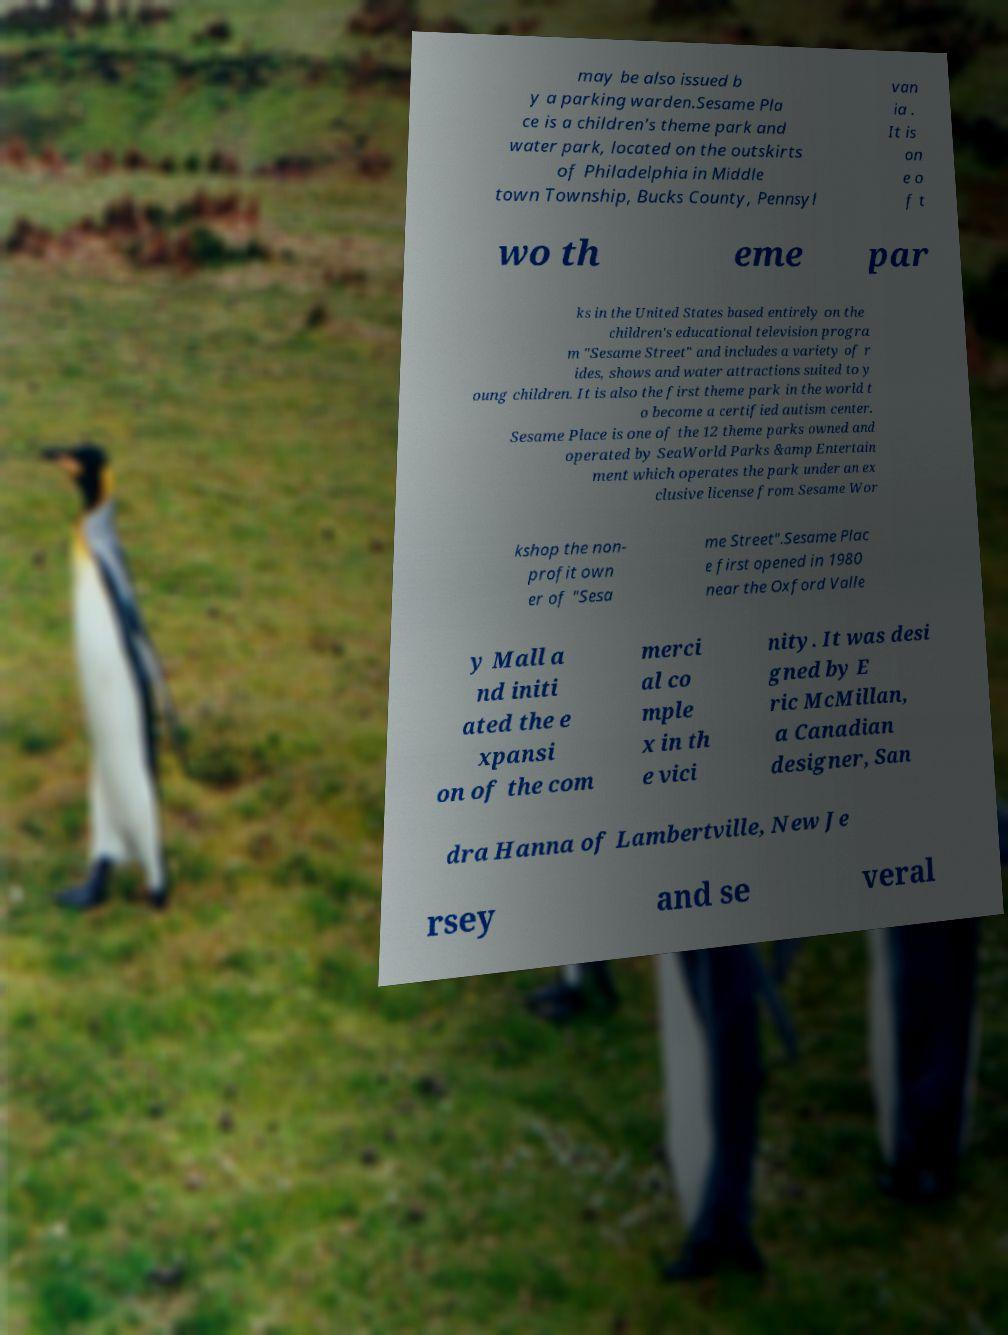Could you extract and type out the text from this image? may be also issued b y a parking warden.Sesame Pla ce is a children's theme park and water park, located on the outskirts of Philadelphia in Middle town Township, Bucks County, Pennsyl van ia . It is on e o f t wo th eme par ks in the United States based entirely on the children's educational television progra m "Sesame Street" and includes a variety of r ides, shows and water attractions suited to y oung children. It is also the first theme park in the world t o become a certified autism center. Sesame Place is one of the 12 theme parks owned and operated by SeaWorld Parks &amp Entertain ment which operates the park under an ex clusive license from Sesame Wor kshop the non- profit own er of "Sesa me Street".Sesame Plac e first opened in 1980 near the Oxford Valle y Mall a nd initi ated the e xpansi on of the com merci al co mple x in th e vici nity. It was desi gned by E ric McMillan, a Canadian designer, San dra Hanna of Lambertville, New Je rsey and se veral 